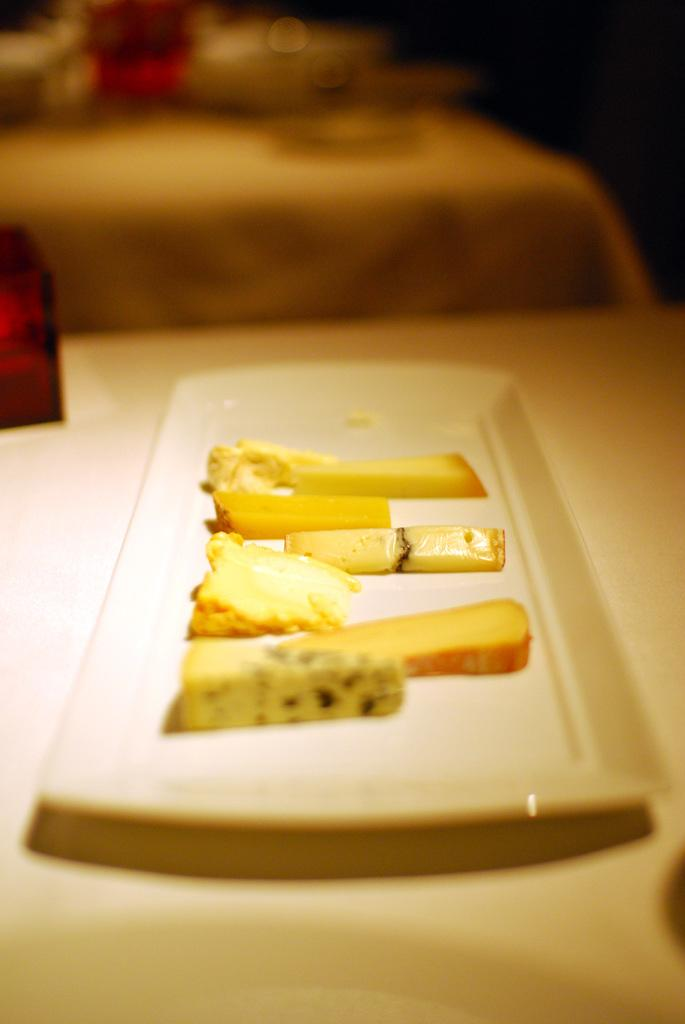What is on the plate that is visible in the image? There is food in a plate in the image. Where is the plate located in the image? The plate is placed on a table. How does the zephyr affect the food on the plate in the image? There is no mention of a zephyr or any wind in the image, so it cannot affect the food on the plate. 